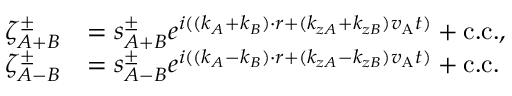Convert formula to latex. <formula><loc_0><loc_0><loc_500><loc_500>\begin{array} { r l } { \zeta _ { A + B } ^ { \pm } } & { = s _ { A + B } ^ { \pm } e ^ { i ( ( k _ { A } + k _ { B } ) \cdot r + ( k _ { z A } + k _ { z B } ) v _ { A } t ) } + c . c . , } \\ { \zeta _ { A - B } ^ { \pm } } & { = s _ { A - B } ^ { \pm } e ^ { i ( ( k _ { A } - k _ { B } ) \cdot r + ( k _ { z A } - k _ { z B } ) v _ { A } t ) } + c . c . } \end{array}</formula> 